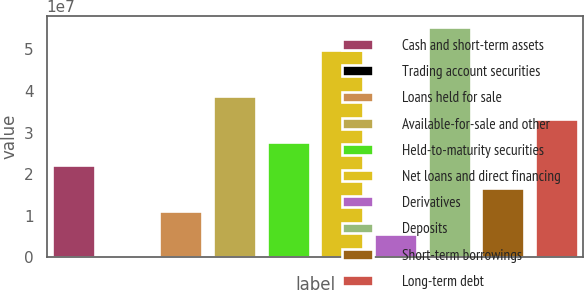<chart> <loc_0><loc_0><loc_500><loc_500><bar_chart><fcel>Cash and short-term assets<fcel>Trading account securities<fcel>Loans held for sale<fcel>Available-for-sale and other<fcel>Held-to-maturity securities<fcel>Net loans and direct financing<fcel>Derivatives<fcel>Deposits<fcel>Short-term borrowings<fcel>Long-term debt<nl><fcel>2.21402e+07<fcel>36997<fcel>1.10886e+07<fcel>3.87176e+07<fcel>2.7666e+07<fcel>4.97433e+07<fcel>5.5628e+06<fcel>5.5295e+07<fcel>1.66144e+07<fcel>3.31918e+07<nl></chart> 